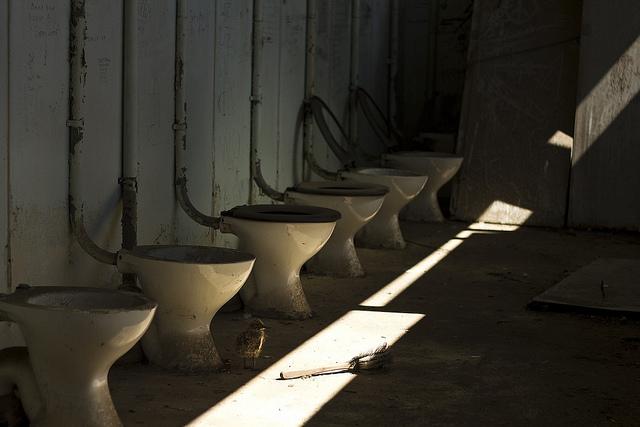How many cups are hanged up?
Give a very brief answer. 0. Are the toilets clean?
Write a very short answer. No. What color are the toilet seats?
Be succinct. White. What is inside the second toilet?
Short answer required. Water. How many toilets are there?
Give a very brief answer. 6. 